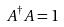Convert formula to latex. <formula><loc_0><loc_0><loc_500><loc_500>A ^ { \dagger } A = 1</formula> 